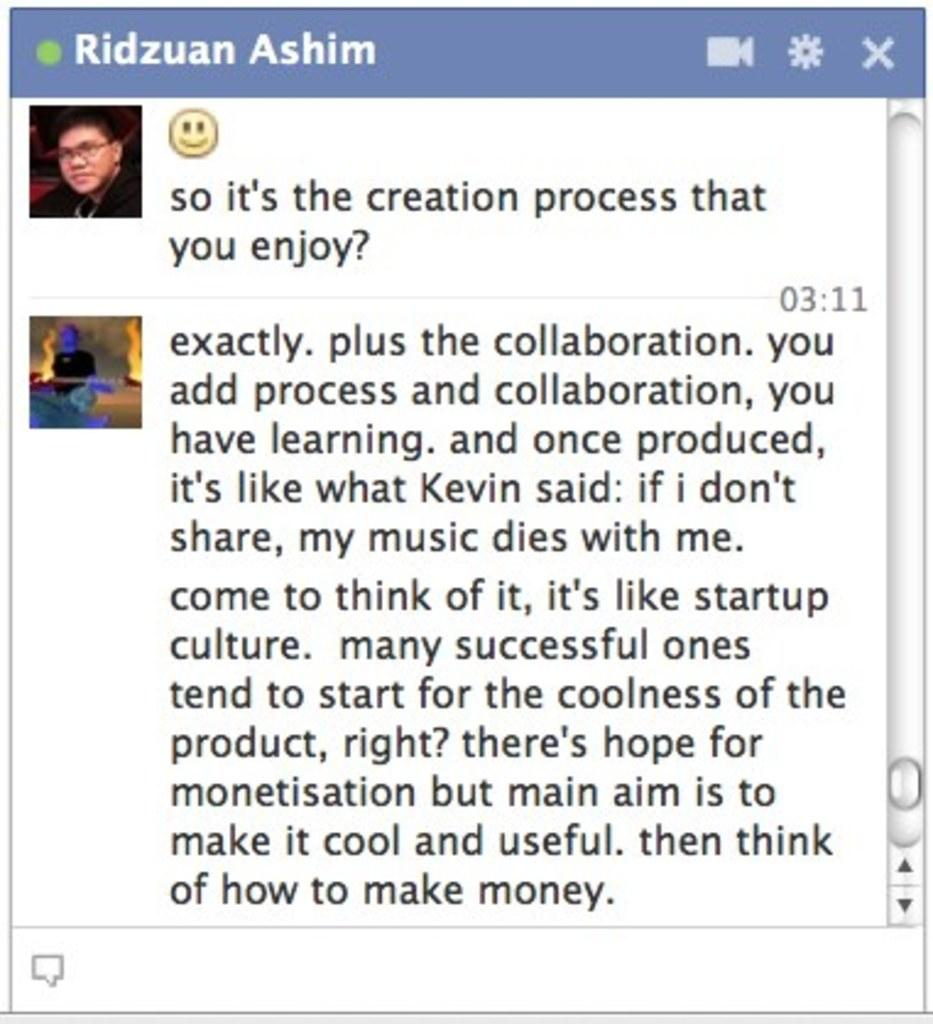What type of content is displayed in the image? The image contains a screenshot of a chat. Can you describe the content of the chat? There is written matter on the screenshot. Are there any visual elements in the chat? Yes, there are two images at the top left of the screenshot. How many cattle can be seen in the chat screenshot? There are no cattle present in the chat screenshot; it contains written matter and images. What type of sock is being discussed in the chat? There is no mention of a sock in the chat screenshot; it contains written matter and images related to a different topic. 